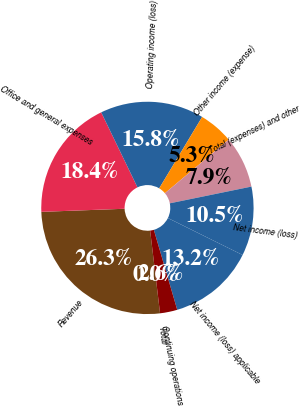<chart> <loc_0><loc_0><loc_500><loc_500><pie_chart><fcel>Revenue<fcel>Office and general expenses<fcel>Operating income (loss)<fcel>Other income (expense)<fcel>Total (expenses) and other<fcel>Net income (loss)<fcel>Net income (loss) applicable<fcel>Continuing operations<fcel>Total<nl><fcel>26.31%<fcel>18.42%<fcel>15.79%<fcel>5.26%<fcel>7.9%<fcel>10.53%<fcel>13.16%<fcel>2.63%<fcel>0.0%<nl></chart> 